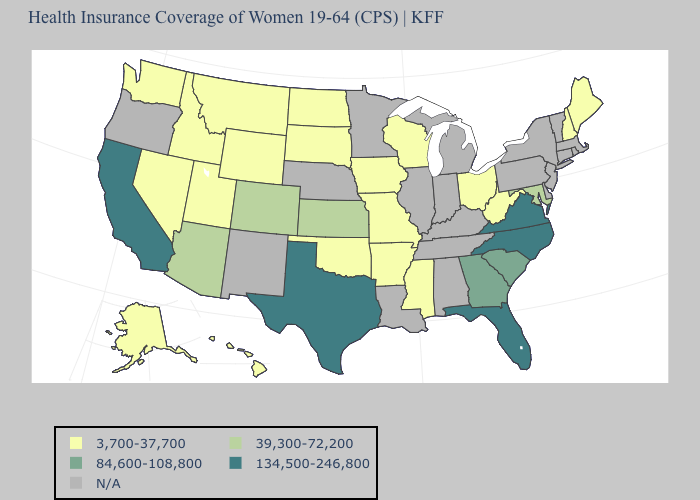Name the states that have a value in the range 39,300-72,200?
Quick response, please. Arizona, Colorado, Kansas, Maryland. Does Kansas have the highest value in the MidWest?
Keep it brief. Yes. Does the first symbol in the legend represent the smallest category?
Give a very brief answer. Yes. Among the states that border Kansas , does Missouri have the lowest value?
Write a very short answer. Yes. Name the states that have a value in the range 39,300-72,200?
Short answer required. Arizona, Colorado, Kansas, Maryland. What is the value of Rhode Island?
Give a very brief answer. N/A. What is the value of Idaho?
Concise answer only. 3,700-37,700. What is the value of New York?
Keep it brief. N/A. Name the states that have a value in the range 3,700-37,700?
Give a very brief answer. Alaska, Arkansas, Hawaii, Idaho, Iowa, Maine, Mississippi, Missouri, Montana, Nevada, New Hampshire, North Dakota, Ohio, Oklahoma, South Dakota, Utah, Washington, West Virginia, Wisconsin, Wyoming. What is the value of Kansas?
Answer briefly. 39,300-72,200. Does the map have missing data?
Keep it brief. Yes. Among the states that border South Dakota , which have the lowest value?
Quick response, please. Iowa, Montana, North Dakota, Wyoming. 